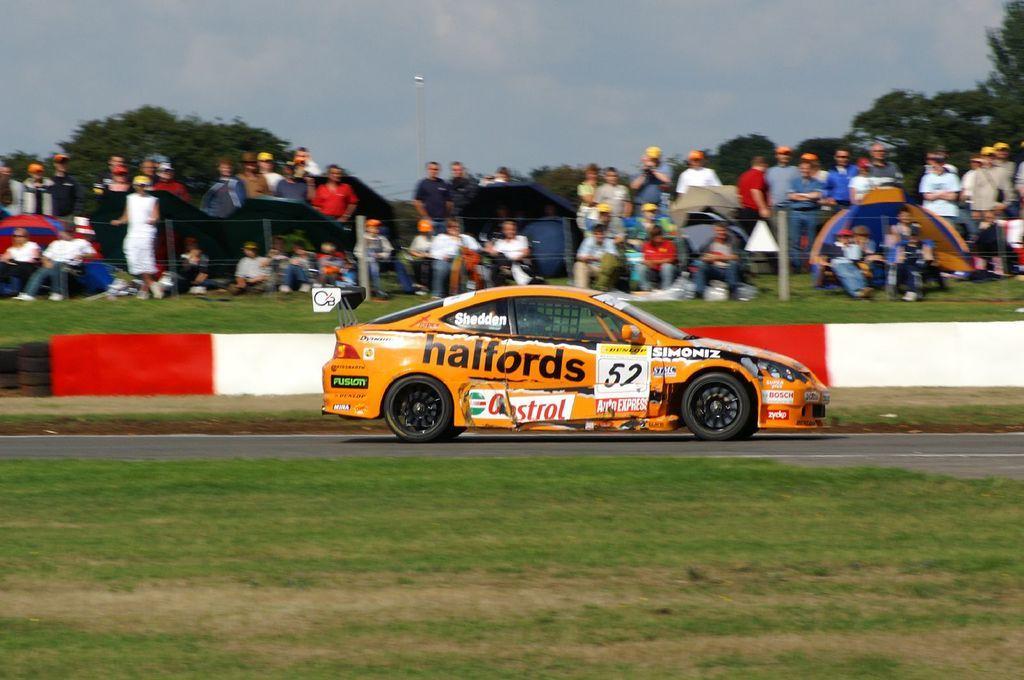How would you summarize this image in a sentence or two? In this picture we can see grass at the bottom, there is a car traveling on the road, in the background there are some people standing and some people are sitting, we can also see trees in the background, there is the sky at the top of the picture, on the right side we can see a tent. 